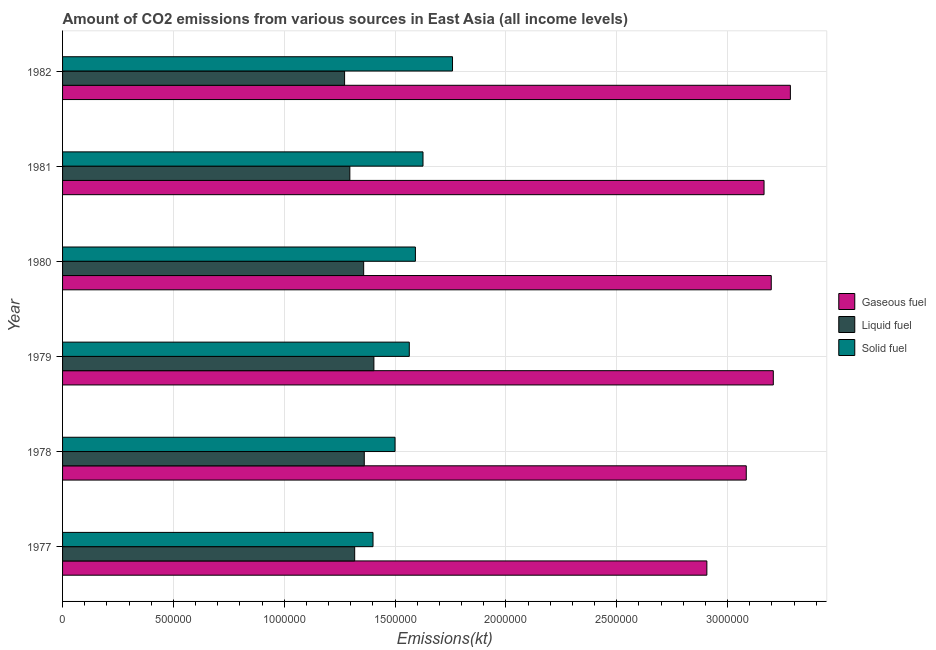Are the number of bars per tick equal to the number of legend labels?
Ensure brevity in your answer.  Yes. How many bars are there on the 6th tick from the bottom?
Provide a succinct answer. 3. What is the label of the 6th group of bars from the top?
Ensure brevity in your answer.  1977. In how many cases, is the number of bars for a given year not equal to the number of legend labels?
Make the answer very short. 0. What is the amount of co2 emissions from liquid fuel in 1982?
Make the answer very short. 1.27e+06. Across all years, what is the maximum amount of co2 emissions from liquid fuel?
Offer a very short reply. 1.40e+06. Across all years, what is the minimum amount of co2 emissions from liquid fuel?
Give a very brief answer. 1.27e+06. In which year was the amount of co2 emissions from gaseous fuel minimum?
Provide a short and direct response. 1977. What is the total amount of co2 emissions from liquid fuel in the graph?
Provide a succinct answer. 8.01e+06. What is the difference between the amount of co2 emissions from liquid fuel in 1978 and that in 1980?
Provide a succinct answer. 2812.53. What is the difference between the amount of co2 emissions from gaseous fuel in 1980 and the amount of co2 emissions from solid fuel in 1978?
Keep it short and to the point. 1.70e+06. What is the average amount of co2 emissions from liquid fuel per year?
Ensure brevity in your answer.  1.34e+06. In the year 1980, what is the difference between the amount of co2 emissions from solid fuel and amount of co2 emissions from gaseous fuel?
Make the answer very short. -1.61e+06. In how many years, is the amount of co2 emissions from solid fuel greater than 1500000 kt?
Your answer should be compact. 4. What is the ratio of the amount of co2 emissions from solid fuel in 1978 to that in 1981?
Your answer should be compact. 0.92. Is the difference between the amount of co2 emissions from liquid fuel in 1979 and 1980 greater than the difference between the amount of co2 emissions from gaseous fuel in 1979 and 1980?
Your answer should be compact. Yes. What is the difference between the highest and the second highest amount of co2 emissions from solid fuel?
Keep it short and to the point. 1.33e+05. What is the difference between the highest and the lowest amount of co2 emissions from gaseous fuel?
Your answer should be compact. 3.77e+05. In how many years, is the amount of co2 emissions from solid fuel greater than the average amount of co2 emissions from solid fuel taken over all years?
Your answer should be compact. 3. Is the sum of the amount of co2 emissions from liquid fuel in 1977 and 1979 greater than the maximum amount of co2 emissions from solid fuel across all years?
Provide a succinct answer. Yes. What does the 1st bar from the top in 1982 represents?
Provide a short and direct response. Solid fuel. What does the 3rd bar from the bottom in 1981 represents?
Your response must be concise. Solid fuel. How many bars are there?
Your answer should be compact. 18. How many years are there in the graph?
Ensure brevity in your answer.  6. Does the graph contain any zero values?
Offer a very short reply. No. Does the graph contain grids?
Offer a terse response. Yes. How are the legend labels stacked?
Keep it short and to the point. Vertical. What is the title of the graph?
Provide a short and direct response. Amount of CO2 emissions from various sources in East Asia (all income levels). What is the label or title of the X-axis?
Make the answer very short. Emissions(kt). What is the Emissions(kt) in Gaseous fuel in 1977?
Provide a short and direct response. 2.91e+06. What is the Emissions(kt) of Liquid fuel in 1977?
Provide a succinct answer. 1.32e+06. What is the Emissions(kt) in Solid fuel in 1977?
Make the answer very short. 1.40e+06. What is the Emissions(kt) in Gaseous fuel in 1978?
Your response must be concise. 3.08e+06. What is the Emissions(kt) in Liquid fuel in 1978?
Give a very brief answer. 1.36e+06. What is the Emissions(kt) of Solid fuel in 1978?
Provide a short and direct response. 1.50e+06. What is the Emissions(kt) in Gaseous fuel in 1979?
Ensure brevity in your answer.  3.21e+06. What is the Emissions(kt) in Liquid fuel in 1979?
Make the answer very short. 1.40e+06. What is the Emissions(kt) in Solid fuel in 1979?
Provide a short and direct response. 1.56e+06. What is the Emissions(kt) in Gaseous fuel in 1980?
Your answer should be compact. 3.20e+06. What is the Emissions(kt) of Liquid fuel in 1980?
Your answer should be compact. 1.36e+06. What is the Emissions(kt) in Solid fuel in 1980?
Ensure brevity in your answer.  1.59e+06. What is the Emissions(kt) of Gaseous fuel in 1981?
Offer a terse response. 3.16e+06. What is the Emissions(kt) of Liquid fuel in 1981?
Make the answer very short. 1.30e+06. What is the Emissions(kt) of Solid fuel in 1981?
Offer a terse response. 1.63e+06. What is the Emissions(kt) of Gaseous fuel in 1982?
Provide a succinct answer. 3.28e+06. What is the Emissions(kt) of Liquid fuel in 1982?
Provide a short and direct response. 1.27e+06. What is the Emissions(kt) of Solid fuel in 1982?
Ensure brevity in your answer.  1.76e+06. Across all years, what is the maximum Emissions(kt) in Gaseous fuel?
Make the answer very short. 3.28e+06. Across all years, what is the maximum Emissions(kt) of Liquid fuel?
Your response must be concise. 1.40e+06. Across all years, what is the maximum Emissions(kt) in Solid fuel?
Make the answer very short. 1.76e+06. Across all years, what is the minimum Emissions(kt) of Gaseous fuel?
Keep it short and to the point. 2.91e+06. Across all years, what is the minimum Emissions(kt) in Liquid fuel?
Ensure brevity in your answer.  1.27e+06. Across all years, what is the minimum Emissions(kt) of Solid fuel?
Your answer should be compact. 1.40e+06. What is the total Emissions(kt) in Gaseous fuel in the graph?
Provide a succinct answer. 1.88e+07. What is the total Emissions(kt) in Liquid fuel in the graph?
Give a very brief answer. 8.01e+06. What is the total Emissions(kt) in Solid fuel in the graph?
Give a very brief answer. 9.44e+06. What is the difference between the Emissions(kt) in Gaseous fuel in 1977 and that in 1978?
Your response must be concise. -1.78e+05. What is the difference between the Emissions(kt) of Liquid fuel in 1977 and that in 1978?
Your answer should be very brief. -4.33e+04. What is the difference between the Emissions(kt) in Solid fuel in 1977 and that in 1978?
Your response must be concise. -9.94e+04. What is the difference between the Emissions(kt) in Gaseous fuel in 1977 and that in 1979?
Provide a succinct answer. -3.00e+05. What is the difference between the Emissions(kt) of Liquid fuel in 1977 and that in 1979?
Provide a short and direct response. -8.66e+04. What is the difference between the Emissions(kt) of Solid fuel in 1977 and that in 1979?
Give a very brief answer. -1.64e+05. What is the difference between the Emissions(kt) of Gaseous fuel in 1977 and that in 1980?
Keep it short and to the point. -2.91e+05. What is the difference between the Emissions(kt) of Liquid fuel in 1977 and that in 1980?
Give a very brief answer. -4.05e+04. What is the difference between the Emissions(kt) in Solid fuel in 1977 and that in 1980?
Make the answer very short. -1.91e+05. What is the difference between the Emissions(kt) of Gaseous fuel in 1977 and that in 1981?
Make the answer very short. -2.58e+05. What is the difference between the Emissions(kt) in Liquid fuel in 1977 and that in 1981?
Provide a short and direct response. 2.18e+04. What is the difference between the Emissions(kt) in Solid fuel in 1977 and that in 1981?
Provide a succinct answer. -2.25e+05. What is the difference between the Emissions(kt) in Gaseous fuel in 1977 and that in 1982?
Provide a short and direct response. -3.77e+05. What is the difference between the Emissions(kt) in Liquid fuel in 1977 and that in 1982?
Provide a short and direct response. 4.55e+04. What is the difference between the Emissions(kt) in Solid fuel in 1977 and that in 1982?
Give a very brief answer. -3.59e+05. What is the difference between the Emissions(kt) of Gaseous fuel in 1978 and that in 1979?
Provide a short and direct response. -1.22e+05. What is the difference between the Emissions(kt) of Liquid fuel in 1978 and that in 1979?
Your response must be concise. -4.33e+04. What is the difference between the Emissions(kt) in Solid fuel in 1978 and that in 1979?
Provide a succinct answer. -6.43e+04. What is the difference between the Emissions(kt) of Gaseous fuel in 1978 and that in 1980?
Your answer should be very brief. -1.13e+05. What is the difference between the Emissions(kt) of Liquid fuel in 1978 and that in 1980?
Your answer should be compact. 2812.53. What is the difference between the Emissions(kt) in Solid fuel in 1978 and that in 1980?
Keep it short and to the point. -9.19e+04. What is the difference between the Emissions(kt) in Gaseous fuel in 1978 and that in 1981?
Make the answer very short. -8.03e+04. What is the difference between the Emissions(kt) of Liquid fuel in 1978 and that in 1981?
Keep it short and to the point. 6.51e+04. What is the difference between the Emissions(kt) of Solid fuel in 1978 and that in 1981?
Give a very brief answer. -1.26e+05. What is the difference between the Emissions(kt) of Gaseous fuel in 1978 and that in 1982?
Give a very brief answer. -1.99e+05. What is the difference between the Emissions(kt) in Liquid fuel in 1978 and that in 1982?
Offer a very short reply. 8.88e+04. What is the difference between the Emissions(kt) of Solid fuel in 1978 and that in 1982?
Give a very brief answer. -2.59e+05. What is the difference between the Emissions(kt) in Gaseous fuel in 1979 and that in 1980?
Keep it short and to the point. 9265.66. What is the difference between the Emissions(kt) of Liquid fuel in 1979 and that in 1980?
Keep it short and to the point. 4.61e+04. What is the difference between the Emissions(kt) in Solid fuel in 1979 and that in 1980?
Offer a terse response. -2.76e+04. What is the difference between the Emissions(kt) of Gaseous fuel in 1979 and that in 1981?
Give a very brief answer. 4.18e+04. What is the difference between the Emissions(kt) of Liquid fuel in 1979 and that in 1981?
Your answer should be compact. 1.08e+05. What is the difference between the Emissions(kt) of Solid fuel in 1979 and that in 1981?
Offer a very short reply. -6.18e+04. What is the difference between the Emissions(kt) in Gaseous fuel in 1979 and that in 1982?
Make the answer very short. -7.70e+04. What is the difference between the Emissions(kt) in Liquid fuel in 1979 and that in 1982?
Ensure brevity in your answer.  1.32e+05. What is the difference between the Emissions(kt) in Solid fuel in 1979 and that in 1982?
Make the answer very short. -1.95e+05. What is the difference between the Emissions(kt) in Gaseous fuel in 1980 and that in 1981?
Ensure brevity in your answer.  3.25e+04. What is the difference between the Emissions(kt) in Liquid fuel in 1980 and that in 1981?
Give a very brief answer. 6.23e+04. What is the difference between the Emissions(kt) of Solid fuel in 1980 and that in 1981?
Your response must be concise. -3.42e+04. What is the difference between the Emissions(kt) in Gaseous fuel in 1980 and that in 1982?
Offer a terse response. -8.62e+04. What is the difference between the Emissions(kt) in Liquid fuel in 1980 and that in 1982?
Your response must be concise. 8.60e+04. What is the difference between the Emissions(kt) in Solid fuel in 1980 and that in 1982?
Give a very brief answer. -1.67e+05. What is the difference between the Emissions(kt) in Gaseous fuel in 1981 and that in 1982?
Provide a succinct answer. -1.19e+05. What is the difference between the Emissions(kt) of Liquid fuel in 1981 and that in 1982?
Your answer should be compact. 2.37e+04. What is the difference between the Emissions(kt) in Solid fuel in 1981 and that in 1982?
Provide a succinct answer. -1.33e+05. What is the difference between the Emissions(kt) in Gaseous fuel in 1977 and the Emissions(kt) in Liquid fuel in 1978?
Offer a terse response. 1.55e+06. What is the difference between the Emissions(kt) in Gaseous fuel in 1977 and the Emissions(kt) in Solid fuel in 1978?
Ensure brevity in your answer.  1.41e+06. What is the difference between the Emissions(kt) in Liquid fuel in 1977 and the Emissions(kt) in Solid fuel in 1978?
Make the answer very short. -1.82e+05. What is the difference between the Emissions(kt) in Gaseous fuel in 1977 and the Emissions(kt) in Liquid fuel in 1979?
Offer a very short reply. 1.50e+06. What is the difference between the Emissions(kt) in Gaseous fuel in 1977 and the Emissions(kt) in Solid fuel in 1979?
Give a very brief answer. 1.34e+06. What is the difference between the Emissions(kt) of Liquid fuel in 1977 and the Emissions(kt) of Solid fuel in 1979?
Provide a succinct answer. -2.46e+05. What is the difference between the Emissions(kt) in Gaseous fuel in 1977 and the Emissions(kt) in Liquid fuel in 1980?
Give a very brief answer. 1.55e+06. What is the difference between the Emissions(kt) in Gaseous fuel in 1977 and the Emissions(kt) in Solid fuel in 1980?
Offer a very short reply. 1.31e+06. What is the difference between the Emissions(kt) of Liquid fuel in 1977 and the Emissions(kt) of Solid fuel in 1980?
Give a very brief answer. -2.74e+05. What is the difference between the Emissions(kt) in Gaseous fuel in 1977 and the Emissions(kt) in Liquid fuel in 1981?
Provide a short and direct response. 1.61e+06. What is the difference between the Emissions(kt) in Gaseous fuel in 1977 and the Emissions(kt) in Solid fuel in 1981?
Offer a very short reply. 1.28e+06. What is the difference between the Emissions(kt) in Liquid fuel in 1977 and the Emissions(kt) in Solid fuel in 1981?
Ensure brevity in your answer.  -3.08e+05. What is the difference between the Emissions(kt) of Gaseous fuel in 1977 and the Emissions(kt) of Liquid fuel in 1982?
Your answer should be very brief. 1.63e+06. What is the difference between the Emissions(kt) of Gaseous fuel in 1977 and the Emissions(kt) of Solid fuel in 1982?
Give a very brief answer. 1.15e+06. What is the difference between the Emissions(kt) in Liquid fuel in 1977 and the Emissions(kt) in Solid fuel in 1982?
Provide a short and direct response. -4.41e+05. What is the difference between the Emissions(kt) of Gaseous fuel in 1978 and the Emissions(kt) of Liquid fuel in 1979?
Keep it short and to the point. 1.68e+06. What is the difference between the Emissions(kt) in Gaseous fuel in 1978 and the Emissions(kt) in Solid fuel in 1979?
Provide a short and direct response. 1.52e+06. What is the difference between the Emissions(kt) in Liquid fuel in 1978 and the Emissions(kt) in Solid fuel in 1979?
Provide a short and direct response. -2.03e+05. What is the difference between the Emissions(kt) in Gaseous fuel in 1978 and the Emissions(kt) in Liquid fuel in 1980?
Your answer should be compact. 1.73e+06. What is the difference between the Emissions(kt) of Gaseous fuel in 1978 and the Emissions(kt) of Solid fuel in 1980?
Give a very brief answer. 1.49e+06. What is the difference between the Emissions(kt) of Liquid fuel in 1978 and the Emissions(kt) of Solid fuel in 1980?
Provide a succinct answer. -2.31e+05. What is the difference between the Emissions(kt) of Gaseous fuel in 1978 and the Emissions(kt) of Liquid fuel in 1981?
Your answer should be very brief. 1.79e+06. What is the difference between the Emissions(kt) of Gaseous fuel in 1978 and the Emissions(kt) of Solid fuel in 1981?
Ensure brevity in your answer.  1.46e+06. What is the difference between the Emissions(kt) in Liquid fuel in 1978 and the Emissions(kt) in Solid fuel in 1981?
Make the answer very short. -2.65e+05. What is the difference between the Emissions(kt) in Gaseous fuel in 1978 and the Emissions(kt) in Liquid fuel in 1982?
Keep it short and to the point. 1.81e+06. What is the difference between the Emissions(kt) of Gaseous fuel in 1978 and the Emissions(kt) of Solid fuel in 1982?
Ensure brevity in your answer.  1.33e+06. What is the difference between the Emissions(kt) in Liquid fuel in 1978 and the Emissions(kt) in Solid fuel in 1982?
Give a very brief answer. -3.98e+05. What is the difference between the Emissions(kt) of Gaseous fuel in 1979 and the Emissions(kt) of Liquid fuel in 1980?
Offer a very short reply. 1.85e+06. What is the difference between the Emissions(kt) of Gaseous fuel in 1979 and the Emissions(kt) of Solid fuel in 1980?
Provide a short and direct response. 1.61e+06. What is the difference between the Emissions(kt) of Liquid fuel in 1979 and the Emissions(kt) of Solid fuel in 1980?
Keep it short and to the point. -1.87e+05. What is the difference between the Emissions(kt) of Gaseous fuel in 1979 and the Emissions(kt) of Liquid fuel in 1981?
Ensure brevity in your answer.  1.91e+06. What is the difference between the Emissions(kt) of Gaseous fuel in 1979 and the Emissions(kt) of Solid fuel in 1981?
Your answer should be compact. 1.58e+06. What is the difference between the Emissions(kt) in Liquid fuel in 1979 and the Emissions(kt) in Solid fuel in 1981?
Your answer should be compact. -2.22e+05. What is the difference between the Emissions(kt) in Gaseous fuel in 1979 and the Emissions(kt) in Liquid fuel in 1982?
Offer a very short reply. 1.93e+06. What is the difference between the Emissions(kt) of Gaseous fuel in 1979 and the Emissions(kt) of Solid fuel in 1982?
Provide a succinct answer. 1.45e+06. What is the difference between the Emissions(kt) in Liquid fuel in 1979 and the Emissions(kt) in Solid fuel in 1982?
Offer a very short reply. -3.55e+05. What is the difference between the Emissions(kt) of Gaseous fuel in 1980 and the Emissions(kt) of Liquid fuel in 1981?
Offer a terse response. 1.90e+06. What is the difference between the Emissions(kt) in Gaseous fuel in 1980 and the Emissions(kt) in Solid fuel in 1981?
Give a very brief answer. 1.57e+06. What is the difference between the Emissions(kt) of Liquid fuel in 1980 and the Emissions(kt) of Solid fuel in 1981?
Ensure brevity in your answer.  -2.68e+05. What is the difference between the Emissions(kt) in Gaseous fuel in 1980 and the Emissions(kt) in Liquid fuel in 1982?
Your answer should be compact. 1.92e+06. What is the difference between the Emissions(kt) of Gaseous fuel in 1980 and the Emissions(kt) of Solid fuel in 1982?
Ensure brevity in your answer.  1.44e+06. What is the difference between the Emissions(kt) in Liquid fuel in 1980 and the Emissions(kt) in Solid fuel in 1982?
Provide a succinct answer. -4.01e+05. What is the difference between the Emissions(kt) in Gaseous fuel in 1981 and the Emissions(kt) in Liquid fuel in 1982?
Your answer should be compact. 1.89e+06. What is the difference between the Emissions(kt) of Gaseous fuel in 1981 and the Emissions(kt) of Solid fuel in 1982?
Offer a very short reply. 1.41e+06. What is the difference between the Emissions(kt) of Liquid fuel in 1981 and the Emissions(kt) of Solid fuel in 1982?
Keep it short and to the point. -4.63e+05. What is the average Emissions(kt) of Gaseous fuel per year?
Your response must be concise. 3.14e+06. What is the average Emissions(kt) of Liquid fuel per year?
Your answer should be very brief. 1.34e+06. What is the average Emissions(kt) of Solid fuel per year?
Make the answer very short. 1.57e+06. In the year 1977, what is the difference between the Emissions(kt) of Gaseous fuel and Emissions(kt) of Liquid fuel?
Your answer should be very brief. 1.59e+06. In the year 1977, what is the difference between the Emissions(kt) in Gaseous fuel and Emissions(kt) in Solid fuel?
Provide a short and direct response. 1.51e+06. In the year 1977, what is the difference between the Emissions(kt) of Liquid fuel and Emissions(kt) of Solid fuel?
Offer a terse response. -8.27e+04. In the year 1978, what is the difference between the Emissions(kt) of Gaseous fuel and Emissions(kt) of Liquid fuel?
Your response must be concise. 1.72e+06. In the year 1978, what is the difference between the Emissions(kt) of Gaseous fuel and Emissions(kt) of Solid fuel?
Provide a short and direct response. 1.58e+06. In the year 1978, what is the difference between the Emissions(kt) in Liquid fuel and Emissions(kt) in Solid fuel?
Your answer should be compact. -1.39e+05. In the year 1979, what is the difference between the Emissions(kt) in Gaseous fuel and Emissions(kt) in Liquid fuel?
Your answer should be very brief. 1.80e+06. In the year 1979, what is the difference between the Emissions(kt) of Gaseous fuel and Emissions(kt) of Solid fuel?
Provide a short and direct response. 1.64e+06. In the year 1979, what is the difference between the Emissions(kt) of Liquid fuel and Emissions(kt) of Solid fuel?
Your response must be concise. -1.60e+05. In the year 1980, what is the difference between the Emissions(kt) of Gaseous fuel and Emissions(kt) of Liquid fuel?
Provide a short and direct response. 1.84e+06. In the year 1980, what is the difference between the Emissions(kt) in Gaseous fuel and Emissions(kt) in Solid fuel?
Keep it short and to the point. 1.61e+06. In the year 1980, what is the difference between the Emissions(kt) of Liquid fuel and Emissions(kt) of Solid fuel?
Provide a succinct answer. -2.33e+05. In the year 1981, what is the difference between the Emissions(kt) in Gaseous fuel and Emissions(kt) in Liquid fuel?
Your response must be concise. 1.87e+06. In the year 1981, what is the difference between the Emissions(kt) in Gaseous fuel and Emissions(kt) in Solid fuel?
Provide a succinct answer. 1.54e+06. In the year 1981, what is the difference between the Emissions(kt) of Liquid fuel and Emissions(kt) of Solid fuel?
Provide a short and direct response. -3.30e+05. In the year 1982, what is the difference between the Emissions(kt) of Gaseous fuel and Emissions(kt) of Liquid fuel?
Your answer should be compact. 2.01e+06. In the year 1982, what is the difference between the Emissions(kt) in Gaseous fuel and Emissions(kt) in Solid fuel?
Your answer should be compact. 1.52e+06. In the year 1982, what is the difference between the Emissions(kt) of Liquid fuel and Emissions(kt) of Solid fuel?
Make the answer very short. -4.87e+05. What is the ratio of the Emissions(kt) of Gaseous fuel in 1977 to that in 1978?
Give a very brief answer. 0.94. What is the ratio of the Emissions(kt) of Liquid fuel in 1977 to that in 1978?
Give a very brief answer. 0.97. What is the ratio of the Emissions(kt) of Solid fuel in 1977 to that in 1978?
Keep it short and to the point. 0.93. What is the ratio of the Emissions(kt) of Gaseous fuel in 1977 to that in 1979?
Provide a short and direct response. 0.91. What is the ratio of the Emissions(kt) of Liquid fuel in 1977 to that in 1979?
Provide a succinct answer. 0.94. What is the ratio of the Emissions(kt) of Solid fuel in 1977 to that in 1979?
Provide a succinct answer. 0.9. What is the ratio of the Emissions(kt) of Gaseous fuel in 1977 to that in 1980?
Ensure brevity in your answer.  0.91. What is the ratio of the Emissions(kt) of Liquid fuel in 1977 to that in 1980?
Make the answer very short. 0.97. What is the ratio of the Emissions(kt) in Solid fuel in 1977 to that in 1980?
Your answer should be compact. 0.88. What is the ratio of the Emissions(kt) in Gaseous fuel in 1977 to that in 1981?
Ensure brevity in your answer.  0.92. What is the ratio of the Emissions(kt) in Liquid fuel in 1977 to that in 1981?
Provide a succinct answer. 1.02. What is the ratio of the Emissions(kt) of Solid fuel in 1977 to that in 1981?
Provide a short and direct response. 0.86. What is the ratio of the Emissions(kt) in Gaseous fuel in 1977 to that in 1982?
Ensure brevity in your answer.  0.89. What is the ratio of the Emissions(kt) of Liquid fuel in 1977 to that in 1982?
Offer a terse response. 1.04. What is the ratio of the Emissions(kt) of Solid fuel in 1977 to that in 1982?
Offer a very short reply. 0.8. What is the ratio of the Emissions(kt) of Gaseous fuel in 1978 to that in 1979?
Provide a short and direct response. 0.96. What is the ratio of the Emissions(kt) of Liquid fuel in 1978 to that in 1979?
Make the answer very short. 0.97. What is the ratio of the Emissions(kt) of Solid fuel in 1978 to that in 1979?
Offer a very short reply. 0.96. What is the ratio of the Emissions(kt) of Gaseous fuel in 1978 to that in 1980?
Ensure brevity in your answer.  0.96. What is the ratio of the Emissions(kt) of Solid fuel in 1978 to that in 1980?
Your response must be concise. 0.94. What is the ratio of the Emissions(kt) in Gaseous fuel in 1978 to that in 1981?
Your answer should be compact. 0.97. What is the ratio of the Emissions(kt) in Liquid fuel in 1978 to that in 1981?
Your answer should be compact. 1.05. What is the ratio of the Emissions(kt) in Solid fuel in 1978 to that in 1981?
Give a very brief answer. 0.92. What is the ratio of the Emissions(kt) in Gaseous fuel in 1978 to that in 1982?
Provide a short and direct response. 0.94. What is the ratio of the Emissions(kt) in Liquid fuel in 1978 to that in 1982?
Provide a short and direct response. 1.07. What is the ratio of the Emissions(kt) in Solid fuel in 1978 to that in 1982?
Provide a short and direct response. 0.85. What is the ratio of the Emissions(kt) in Liquid fuel in 1979 to that in 1980?
Give a very brief answer. 1.03. What is the ratio of the Emissions(kt) of Solid fuel in 1979 to that in 1980?
Offer a terse response. 0.98. What is the ratio of the Emissions(kt) in Gaseous fuel in 1979 to that in 1981?
Provide a succinct answer. 1.01. What is the ratio of the Emissions(kt) in Liquid fuel in 1979 to that in 1981?
Offer a very short reply. 1.08. What is the ratio of the Emissions(kt) of Gaseous fuel in 1979 to that in 1982?
Make the answer very short. 0.98. What is the ratio of the Emissions(kt) of Liquid fuel in 1979 to that in 1982?
Give a very brief answer. 1.1. What is the ratio of the Emissions(kt) in Solid fuel in 1979 to that in 1982?
Make the answer very short. 0.89. What is the ratio of the Emissions(kt) of Gaseous fuel in 1980 to that in 1981?
Keep it short and to the point. 1.01. What is the ratio of the Emissions(kt) in Liquid fuel in 1980 to that in 1981?
Your answer should be very brief. 1.05. What is the ratio of the Emissions(kt) in Gaseous fuel in 1980 to that in 1982?
Keep it short and to the point. 0.97. What is the ratio of the Emissions(kt) in Liquid fuel in 1980 to that in 1982?
Give a very brief answer. 1.07. What is the ratio of the Emissions(kt) in Solid fuel in 1980 to that in 1982?
Make the answer very short. 0.9. What is the ratio of the Emissions(kt) in Gaseous fuel in 1981 to that in 1982?
Provide a short and direct response. 0.96. What is the ratio of the Emissions(kt) in Liquid fuel in 1981 to that in 1982?
Offer a very short reply. 1.02. What is the ratio of the Emissions(kt) of Solid fuel in 1981 to that in 1982?
Offer a terse response. 0.92. What is the difference between the highest and the second highest Emissions(kt) of Gaseous fuel?
Your answer should be compact. 7.70e+04. What is the difference between the highest and the second highest Emissions(kt) in Liquid fuel?
Your response must be concise. 4.33e+04. What is the difference between the highest and the second highest Emissions(kt) in Solid fuel?
Provide a short and direct response. 1.33e+05. What is the difference between the highest and the lowest Emissions(kt) in Gaseous fuel?
Your answer should be compact. 3.77e+05. What is the difference between the highest and the lowest Emissions(kt) of Liquid fuel?
Your answer should be very brief. 1.32e+05. What is the difference between the highest and the lowest Emissions(kt) in Solid fuel?
Keep it short and to the point. 3.59e+05. 